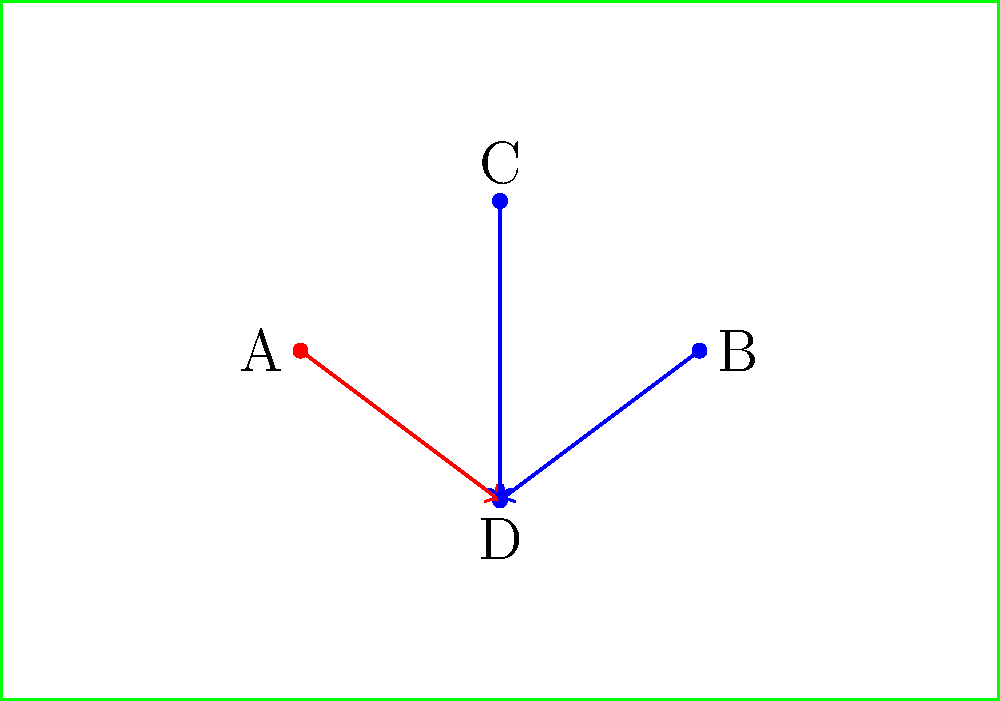In this set-piece situation, which player is most likely to be the target for a cross or pass based on the movement patterns shown? To determine the most likely target for a cross or pass, we need to analyze the movement patterns of the players:

1. Player A (red) is moving towards point D.
2. Players B and C (blue) are also moving towards point D.
3. Player D (blue) is stationary at the convergence point of all movements.

Step-by-step analysis:
1. The red player (A) is likely an attacking player trying to create space or draw defenders.
2. The blue players (B and C) are probably defenders trying to mark or intercept.
3. Player D, being stationary and the focus of all movements, is in a prime position to receive a pass or cross.
4. The converging movements of defenders suggest they are reacting to a potential threat at point D.

Given these observations, player D is most likely the target for a cross or pass. Their stationary position at the convergence point of all player movements indicates they are positioning themselves to receive the ball while the other players create space or attempt to defend.
Answer: Player D 